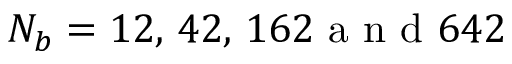Convert formula to latex. <formula><loc_0><loc_0><loc_500><loc_500>N _ { b } = 1 2 , \, 4 2 , \, 1 6 2 a n d 6 4 2</formula> 